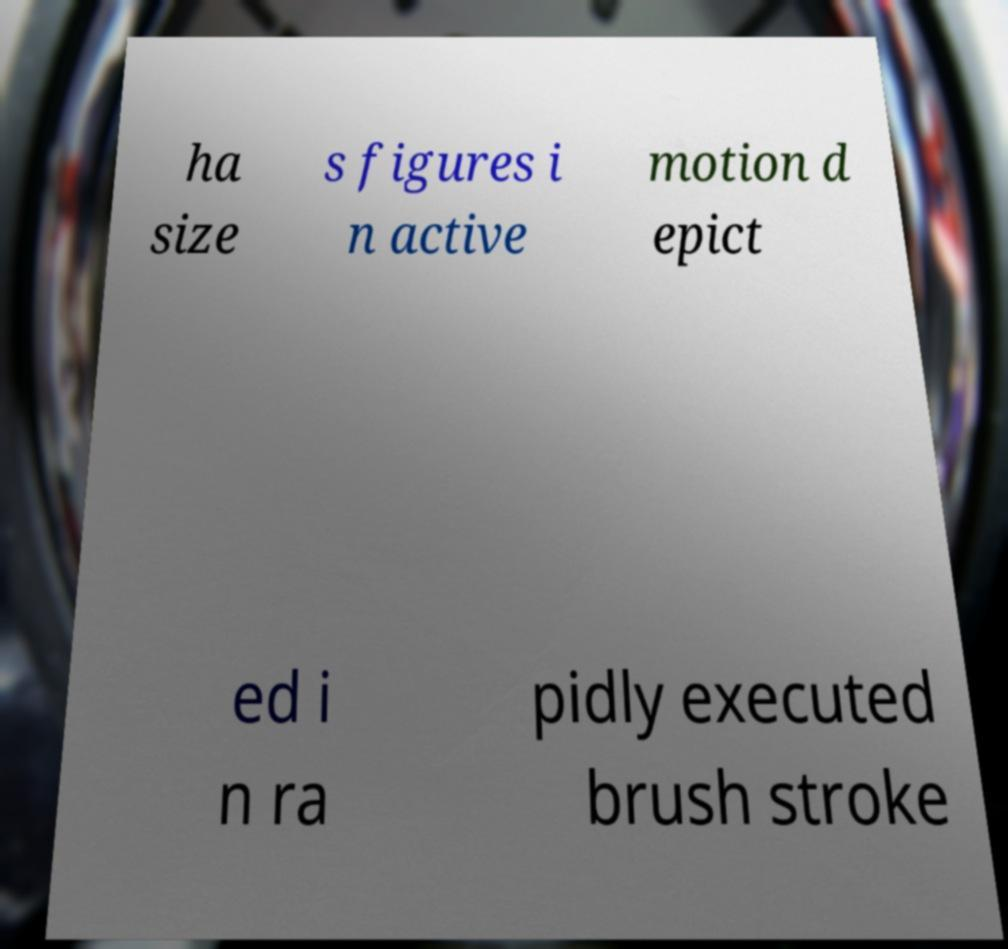For documentation purposes, I need the text within this image transcribed. Could you provide that? ha size s figures i n active motion d epict ed i n ra pidly executed brush stroke 